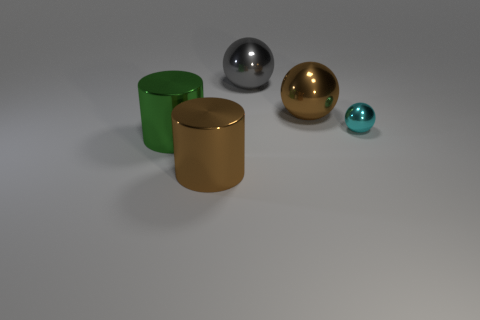Subtract all brown balls. How many balls are left? 2 Subtract all gray balls. How many balls are left? 2 Add 1 big blue metal objects. How many objects exist? 6 Subtract all cylinders. How many objects are left? 3 Subtract 0 cyan blocks. How many objects are left? 5 Subtract 2 cylinders. How many cylinders are left? 0 Subtract all yellow balls. Subtract all cyan cylinders. How many balls are left? 3 Subtract all green cylinders. How many purple balls are left? 0 Subtract all large cyan metal spheres. Subtract all large gray spheres. How many objects are left? 4 Add 5 large green metal things. How many large green metal things are left? 6 